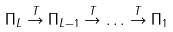<formula> <loc_0><loc_0><loc_500><loc_500>\Pi _ { L } \stackrel { T } { \rightarrow } \Pi _ { L - 1 } \stackrel { T } { \rightarrow } \dots \stackrel { T } { \rightarrow } \Pi _ { 1 }</formula> 